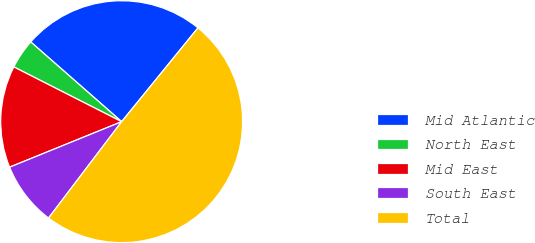Convert chart to OTSL. <chart><loc_0><loc_0><loc_500><loc_500><pie_chart><fcel>Mid Atlantic<fcel>North East<fcel>Mid East<fcel>South East<fcel>Total<nl><fcel>24.41%<fcel>3.98%<fcel>13.62%<fcel>8.53%<fcel>49.46%<nl></chart> 